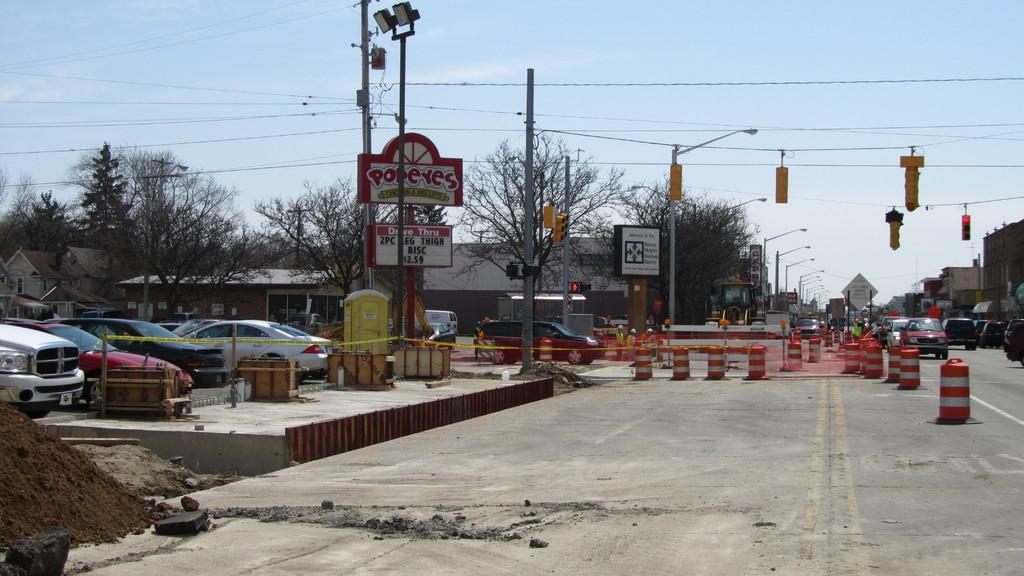<image>
Provide a brief description of the given image. a street in the day with a Pop Eyes chicken building 